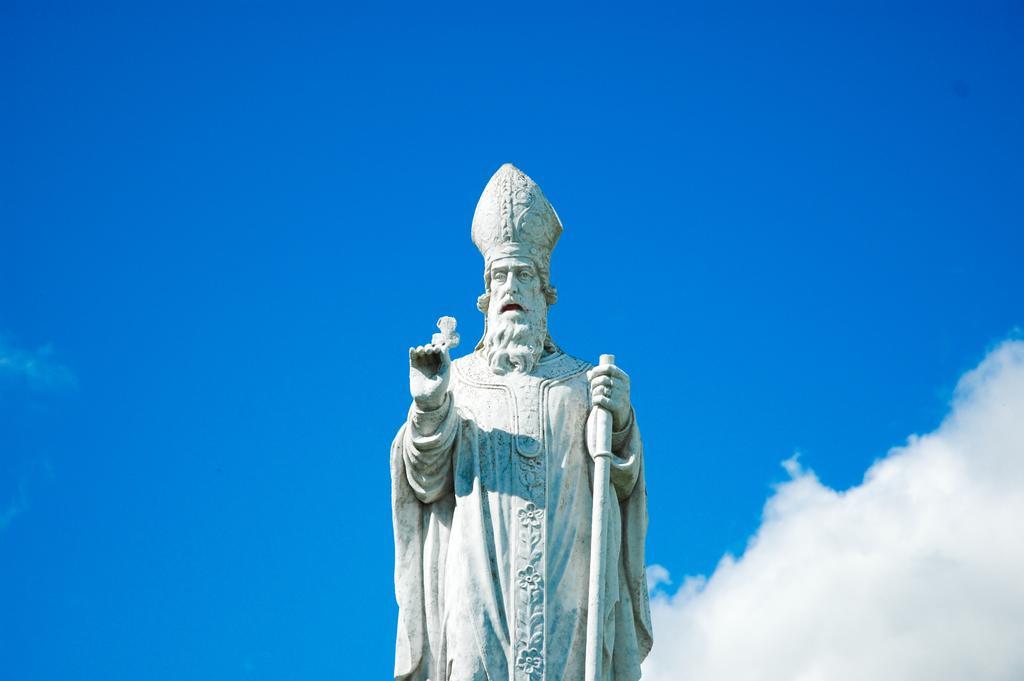Can you describe this image briefly? In this image we can see a white color statue, behind blue sky with cloud is present. 